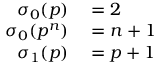<formula> <loc_0><loc_0><loc_500><loc_500>\begin{array} { r l } { \sigma _ { 0 } ( p ) } & = 2 } \\ { \sigma _ { 0 } ( p ^ { n } ) } & = n + 1 } \\ { \sigma _ { 1 } ( p ) } & = p + 1 } \end{array}</formula> 